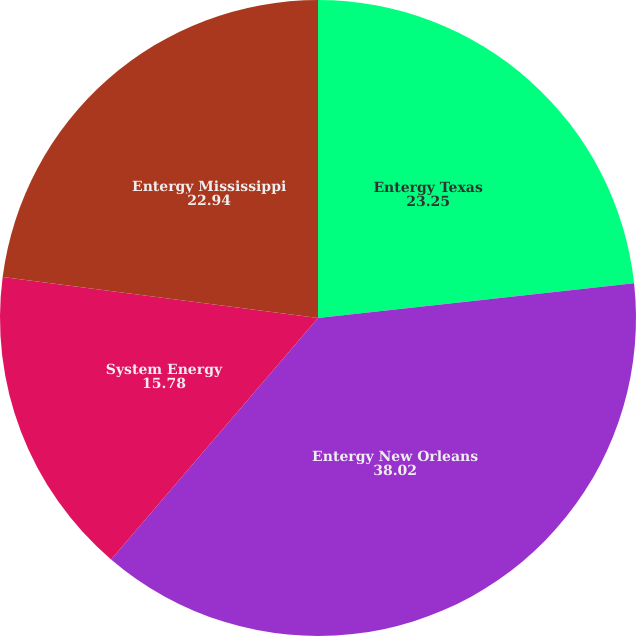<chart> <loc_0><loc_0><loc_500><loc_500><pie_chart><fcel>Entergy Texas<fcel>Entergy New Orleans<fcel>System Energy<fcel>Entergy Mississippi<nl><fcel>23.25%<fcel>38.02%<fcel>15.78%<fcel>22.94%<nl></chart> 